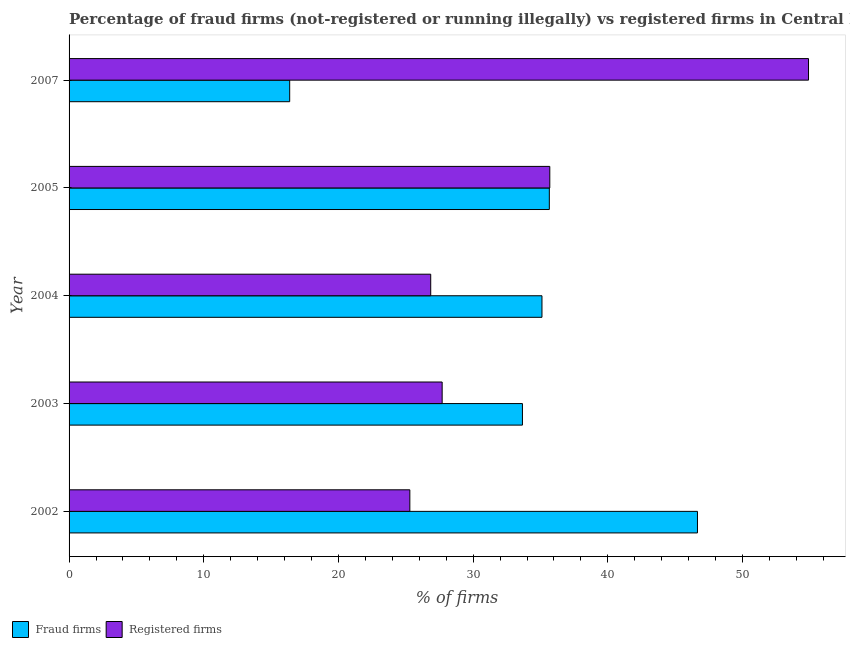How many different coloured bars are there?
Provide a succinct answer. 2. How many groups of bars are there?
Your answer should be compact. 5. In how many cases, is the number of bars for a given year not equal to the number of legend labels?
Offer a terse response. 0. What is the percentage of fraud firms in 2005?
Provide a succinct answer. 35.66. Across all years, what is the maximum percentage of fraud firms?
Ensure brevity in your answer.  46.65. Across all years, what is the minimum percentage of registered firms?
Keep it short and to the point. 25.3. What is the total percentage of fraud firms in the graph?
Offer a very short reply. 167.46. What is the difference between the percentage of registered firms in 2002 and that in 2005?
Your answer should be compact. -10.39. What is the difference between the percentage of fraud firms in 2004 and the percentage of registered firms in 2007?
Offer a very short reply. -19.79. What is the average percentage of registered firms per year?
Provide a succinct answer. 34.09. In the year 2007, what is the difference between the percentage of registered firms and percentage of fraud firms?
Your response must be concise. 38.52. What is the ratio of the percentage of registered firms in 2002 to that in 2004?
Your answer should be very brief. 0.94. Is the difference between the percentage of registered firms in 2003 and 2007 greater than the difference between the percentage of fraud firms in 2003 and 2007?
Offer a terse response. No. What is the difference between the highest and the second highest percentage of registered firms?
Ensure brevity in your answer.  19.21. What is the difference between the highest and the lowest percentage of registered firms?
Make the answer very short. 29.6. Is the sum of the percentage of registered firms in 2002 and 2004 greater than the maximum percentage of fraud firms across all years?
Keep it short and to the point. Yes. What does the 2nd bar from the top in 2003 represents?
Keep it short and to the point. Fraud firms. What does the 2nd bar from the bottom in 2007 represents?
Your response must be concise. Registered firms. Are all the bars in the graph horizontal?
Give a very brief answer. Yes. What is the difference between two consecutive major ticks on the X-axis?
Keep it short and to the point. 10. Does the graph contain any zero values?
Keep it short and to the point. No. Does the graph contain grids?
Keep it short and to the point. No. Where does the legend appear in the graph?
Ensure brevity in your answer.  Bottom left. How are the legend labels stacked?
Offer a terse response. Horizontal. What is the title of the graph?
Ensure brevity in your answer.  Percentage of fraud firms (not-registered or running illegally) vs registered firms in Central Europe. Does "Automatic Teller Machines" appear as one of the legend labels in the graph?
Keep it short and to the point. No. What is the label or title of the X-axis?
Ensure brevity in your answer.  % of firms. What is the % of firms in Fraud firms in 2002?
Provide a short and direct response. 46.65. What is the % of firms in Registered firms in 2002?
Provide a short and direct response. 25.3. What is the % of firms of Fraud firms in 2003?
Your answer should be very brief. 33.66. What is the % of firms of Registered firms in 2003?
Make the answer very short. 27.7. What is the % of firms of Fraud firms in 2004?
Ensure brevity in your answer.  35.11. What is the % of firms in Registered firms in 2004?
Give a very brief answer. 26.85. What is the % of firms in Fraud firms in 2005?
Provide a succinct answer. 35.66. What is the % of firms in Registered firms in 2005?
Your answer should be very brief. 35.69. What is the % of firms in Fraud firms in 2007?
Ensure brevity in your answer.  16.38. What is the % of firms in Registered firms in 2007?
Ensure brevity in your answer.  54.9. Across all years, what is the maximum % of firms of Fraud firms?
Offer a very short reply. 46.65. Across all years, what is the maximum % of firms in Registered firms?
Offer a very short reply. 54.9. Across all years, what is the minimum % of firms in Fraud firms?
Offer a terse response. 16.38. Across all years, what is the minimum % of firms of Registered firms?
Provide a short and direct response. 25.3. What is the total % of firms in Fraud firms in the graph?
Your answer should be compact. 167.46. What is the total % of firms in Registered firms in the graph?
Offer a terse response. 170.44. What is the difference between the % of firms in Fraud firms in 2002 and that in 2003?
Provide a succinct answer. 12.99. What is the difference between the % of firms in Registered firms in 2002 and that in 2003?
Provide a succinct answer. -2.4. What is the difference between the % of firms of Fraud firms in 2002 and that in 2004?
Your answer should be compact. 11.54. What is the difference between the % of firms in Registered firms in 2002 and that in 2004?
Offer a terse response. -1.55. What is the difference between the % of firms in Fraud firms in 2002 and that in 2005?
Keep it short and to the point. 11. What is the difference between the % of firms in Registered firms in 2002 and that in 2005?
Offer a terse response. -10.39. What is the difference between the % of firms of Fraud firms in 2002 and that in 2007?
Give a very brief answer. 30.27. What is the difference between the % of firms in Registered firms in 2002 and that in 2007?
Offer a very short reply. -29.6. What is the difference between the % of firms of Fraud firms in 2003 and that in 2004?
Provide a short and direct response. -1.45. What is the difference between the % of firms in Fraud firms in 2003 and that in 2005?
Your response must be concise. -2. What is the difference between the % of firms in Registered firms in 2003 and that in 2005?
Offer a terse response. -7.99. What is the difference between the % of firms in Fraud firms in 2003 and that in 2007?
Your answer should be compact. 17.28. What is the difference between the % of firms of Registered firms in 2003 and that in 2007?
Make the answer very short. -27.2. What is the difference between the % of firms in Fraud firms in 2004 and that in 2005?
Offer a terse response. -0.55. What is the difference between the % of firms in Registered firms in 2004 and that in 2005?
Provide a succinct answer. -8.84. What is the difference between the % of firms of Fraud firms in 2004 and that in 2007?
Make the answer very short. 18.73. What is the difference between the % of firms of Registered firms in 2004 and that in 2007?
Provide a succinct answer. -28.05. What is the difference between the % of firms in Fraud firms in 2005 and that in 2007?
Your answer should be very brief. 19.28. What is the difference between the % of firms of Registered firms in 2005 and that in 2007?
Make the answer very short. -19.21. What is the difference between the % of firms of Fraud firms in 2002 and the % of firms of Registered firms in 2003?
Offer a very short reply. 18.95. What is the difference between the % of firms of Fraud firms in 2002 and the % of firms of Registered firms in 2004?
Offer a terse response. 19.8. What is the difference between the % of firms of Fraud firms in 2002 and the % of firms of Registered firms in 2005?
Offer a very short reply. 10.96. What is the difference between the % of firms of Fraud firms in 2002 and the % of firms of Registered firms in 2007?
Provide a succinct answer. -8.25. What is the difference between the % of firms in Fraud firms in 2003 and the % of firms in Registered firms in 2004?
Make the answer very short. 6.81. What is the difference between the % of firms in Fraud firms in 2003 and the % of firms in Registered firms in 2005?
Ensure brevity in your answer.  -2.03. What is the difference between the % of firms of Fraud firms in 2003 and the % of firms of Registered firms in 2007?
Keep it short and to the point. -21.24. What is the difference between the % of firms of Fraud firms in 2004 and the % of firms of Registered firms in 2005?
Ensure brevity in your answer.  -0.58. What is the difference between the % of firms of Fraud firms in 2004 and the % of firms of Registered firms in 2007?
Make the answer very short. -19.79. What is the difference between the % of firms of Fraud firms in 2005 and the % of firms of Registered firms in 2007?
Offer a terse response. -19.24. What is the average % of firms of Fraud firms per year?
Provide a succinct answer. 33.49. What is the average % of firms in Registered firms per year?
Your answer should be very brief. 34.09. In the year 2002, what is the difference between the % of firms of Fraud firms and % of firms of Registered firms?
Your answer should be compact. 21.35. In the year 2003, what is the difference between the % of firms of Fraud firms and % of firms of Registered firms?
Provide a succinct answer. 5.96. In the year 2004, what is the difference between the % of firms of Fraud firms and % of firms of Registered firms?
Your answer should be compact. 8.26. In the year 2005, what is the difference between the % of firms of Fraud firms and % of firms of Registered firms?
Your answer should be very brief. -0.03. In the year 2007, what is the difference between the % of firms in Fraud firms and % of firms in Registered firms?
Ensure brevity in your answer.  -38.52. What is the ratio of the % of firms of Fraud firms in 2002 to that in 2003?
Ensure brevity in your answer.  1.39. What is the ratio of the % of firms in Registered firms in 2002 to that in 2003?
Offer a very short reply. 0.91. What is the ratio of the % of firms in Fraud firms in 2002 to that in 2004?
Your answer should be very brief. 1.33. What is the ratio of the % of firms of Registered firms in 2002 to that in 2004?
Keep it short and to the point. 0.94. What is the ratio of the % of firms in Fraud firms in 2002 to that in 2005?
Your answer should be compact. 1.31. What is the ratio of the % of firms of Registered firms in 2002 to that in 2005?
Give a very brief answer. 0.71. What is the ratio of the % of firms of Fraud firms in 2002 to that in 2007?
Offer a very short reply. 2.85. What is the ratio of the % of firms of Registered firms in 2002 to that in 2007?
Your answer should be very brief. 0.46. What is the ratio of the % of firms in Fraud firms in 2003 to that in 2004?
Your response must be concise. 0.96. What is the ratio of the % of firms of Registered firms in 2003 to that in 2004?
Keep it short and to the point. 1.03. What is the ratio of the % of firms in Fraud firms in 2003 to that in 2005?
Offer a very short reply. 0.94. What is the ratio of the % of firms in Registered firms in 2003 to that in 2005?
Give a very brief answer. 0.78. What is the ratio of the % of firms of Fraud firms in 2003 to that in 2007?
Keep it short and to the point. 2.05. What is the ratio of the % of firms of Registered firms in 2003 to that in 2007?
Your answer should be very brief. 0.5. What is the ratio of the % of firms in Fraud firms in 2004 to that in 2005?
Give a very brief answer. 0.98. What is the ratio of the % of firms in Registered firms in 2004 to that in 2005?
Your answer should be compact. 0.75. What is the ratio of the % of firms in Fraud firms in 2004 to that in 2007?
Ensure brevity in your answer.  2.14. What is the ratio of the % of firms in Registered firms in 2004 to that in 2007?
Your answer should be very brief. 0.49. What is the ratio of the % of firms of Fraud firms in 2005 to that in 2007?
Ensure brevity in your answer.  2.18. What is the ratio of the % of firms in Registered firms in 2005 to that in 2007?
Keep it short and to the point. 0.65. What is the difference between the highest and the second highest % of firms in Fraud firms?
Your response must be concise. 11. What is the difference between the highest and the second highest % of firms in Registered firms?
Your answer should be very brief. 19.21. What is the difference between the highest and the lowest % of firms in Fraud firms?
Your response must be concise. 30.27. What is the difference between the highest and the lowest % of firms in Registered firms?
Keep it short and to the point. 29.6. 